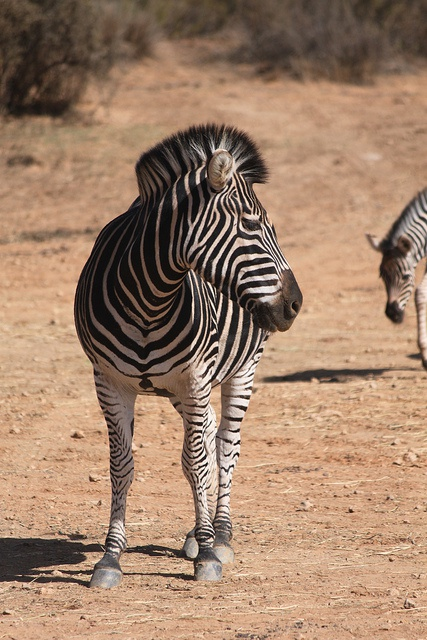Describe the objects in this image and their specific colors. I can see zebra in maroon, black, gray, lightgray, and tan tones and zebra in maroon, black, gray, tan, and darkgray tones in this image. 